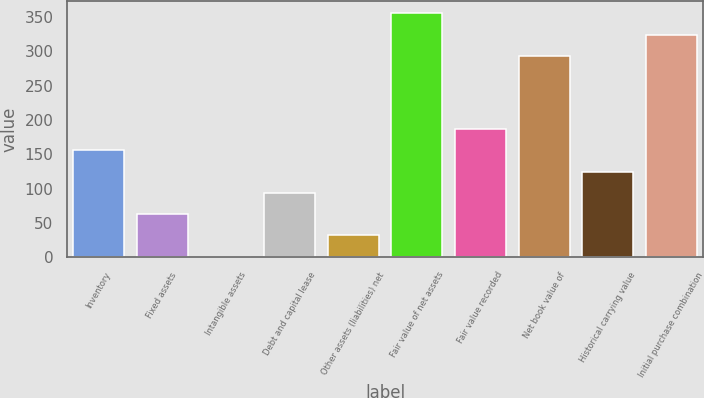Convert chart. <chart><loc_0><loc_0><loc_500><loc_500><bar_chart><fcel>Inventory<fcel>Fixed assets<fcel>Intangible assets<fcel>Debt and capital lease<fcel>Other assets (liabilities) net<fcel>Fair value of net assets<fcel>Fair value recorded<fcel>Net book value of<fcel>Historical carrying value<fcel>Initial purchase combination<nl><fcel>155.5<fcel>62.8<fcel>1<fcel>93.7<fcel>31.9<fcel>354.8<fcel>186.4<fcel>293<fcel>124.6<fcel>323.9<nl></chart> 